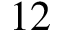<formula> <loc_0><loc_0><loc_500><loc_500>1 2</formula> 